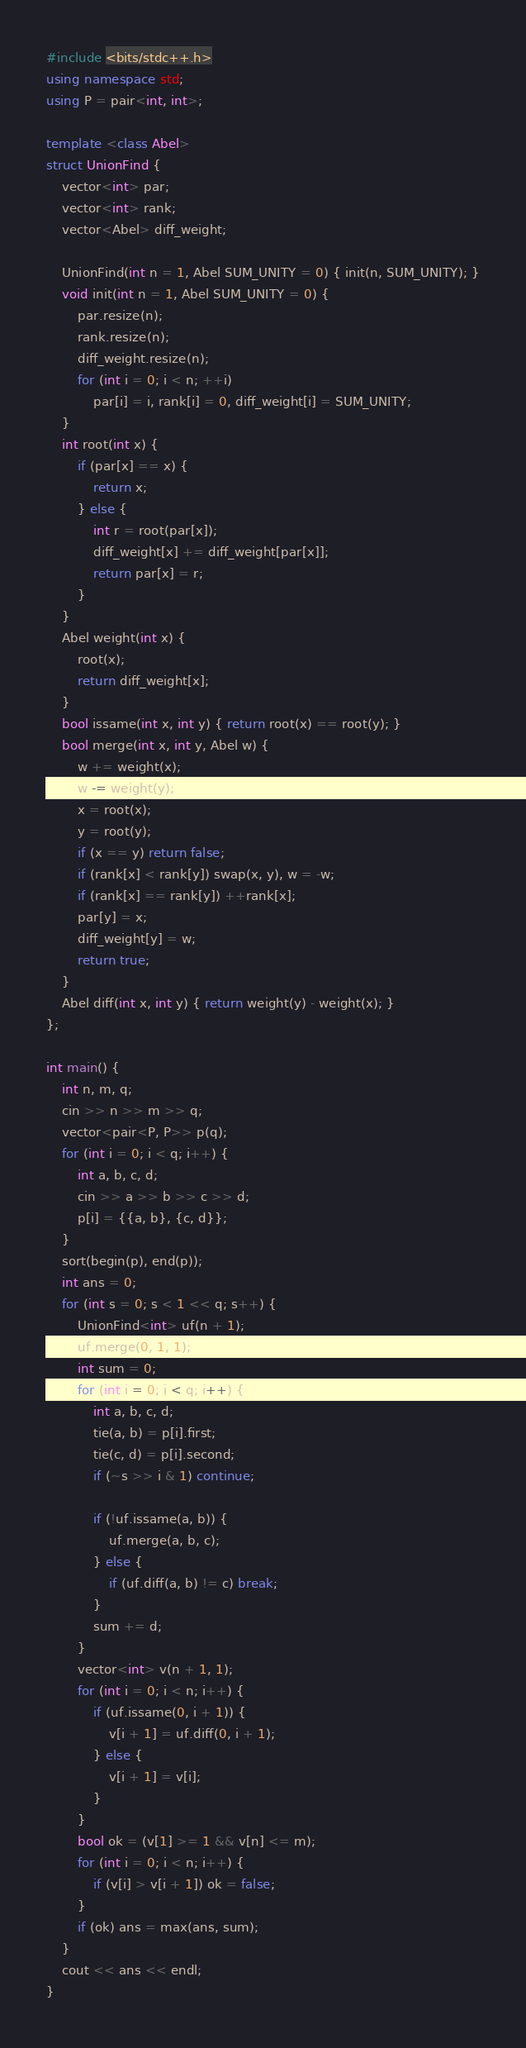Convert code to text. <code><loc_0><loc_0><loc_500><loc_500><_C++_>#include <bits/stdc++.h>
using namespace std;
using P = pair<int, int>;

template <class Abel>
struct UnionFind {
    vector<int> par;
    vector<int> rank;
    vector<Abel> diff_weight;

    UnionFind(int n = 1, Abel SUM_UNITY = 0) { init(n, SUM_UNITY); }
    void init(int n = 1, Abel SUM_UNITY = 0) {
        par.resize(n);
        rank.resize(n);
        diff_weight.resize(n);
        for (int i = 0; i < n; ++i)
            par[i] = i, rank[i] = 0, diff_weight[i] = SUM_UNITY;
    }
    int root(int x) {
        if (par[x] == x) {
            return x;
        } else {
            int r = root(par[x]);
            diff_weight[x] += diff_weight[par[x]];
            return par[x] = r;
        }
    }
    Abel weight(int x) {
        root(x);
        return diff_weight[x];
    }
    bool issame(int x, int y) { return root(x) == root(y); }
    bool merge(int x, int y, Abel w) {
        w += weight(x);
        w -= weight(y);
        x = root(x);
        y = root(y);
        if (x == y) return false;
        if (rank[x] < rank[y]) swap(x, y), w = -w;
        if (rank[x] == rank[y]) ++rank[x];
        par[y] = x;
        diff_weight[y] = w;
        return true;
    }
    Abel diff(int x, int y) { return weight(y) - weight(x); }
};

int main() {
    int n, m, q;
    cin >> n >> m >> q;
    vector<pair<P, P>> p(q);
    for (int i = 0; i < q; i++) {
        int a, b, c, d;
        cin >> a >> b >> c >> d;
        p[i] = {{a, b}, {c, d}};
    }
    sort(begin(p), end(p));
    int ans = 0;
    for (int s = 0; s < 1 << q; s++) {
        UnionFind<int> uf(n + 1);
        uf.merge(0, 1, 1);
        int sum = 0;
        for (int i = 0; i < q; i++) {
            int a, b, c, d;
            tie(a, b) = p[i].first;
            tie(c, d) = p[i].second;
            if (~s >> i & 1) continue;

            if (!uf.issame(a, b)) {
                uf.merge(a, b, c);
            } else {
                if (uf.diff(a, b) != c) break;
            }
            sum += d;
        }
        vector<int> v(n + 1, 1);
        for (int i = 0; i < n; i++) {
            if (uf.issame(0, i + 1)) {
                v[i + 1] = uf.diff(0, i + 1);
            } else {
                v[i + 1] = v[i];
            }
        }
        bool ok = (v[1] >= 1 && v[n] <= m);
        for (int i = 0; i < n; i++) {
            if (v[i] > v[i + 1]) ok = false;
        }
        if (ok) ans = max(ans, sum);
    }
    cout << ans << endl;
}</code> 